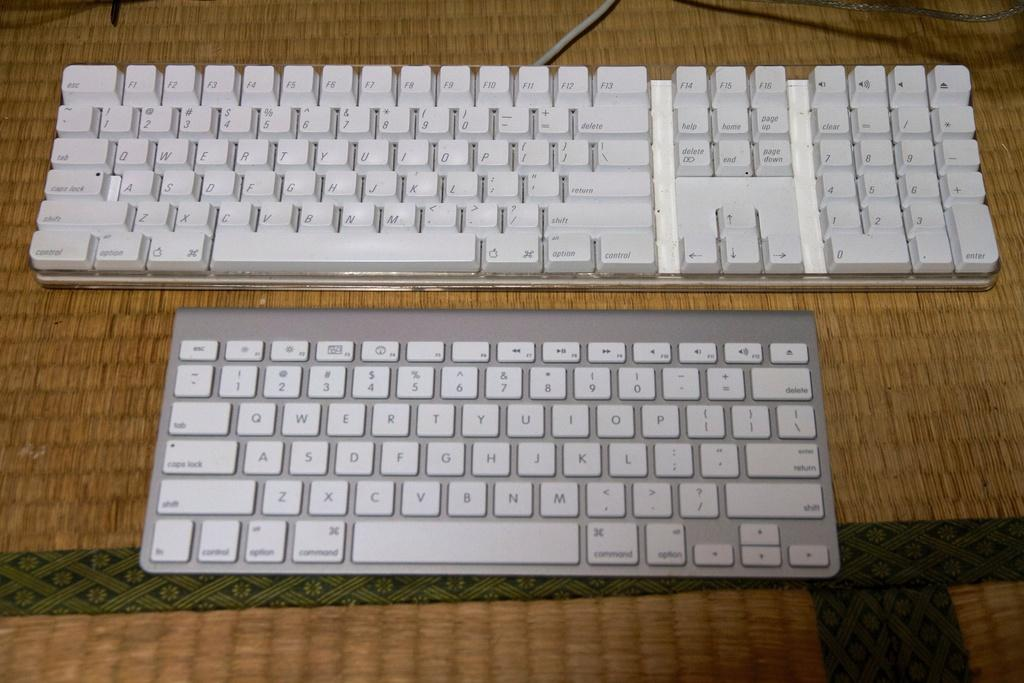<image>
Create a compact narrative representing the image presented. Two keyboard with white keys with ESC keep in the upper left hand corner. 